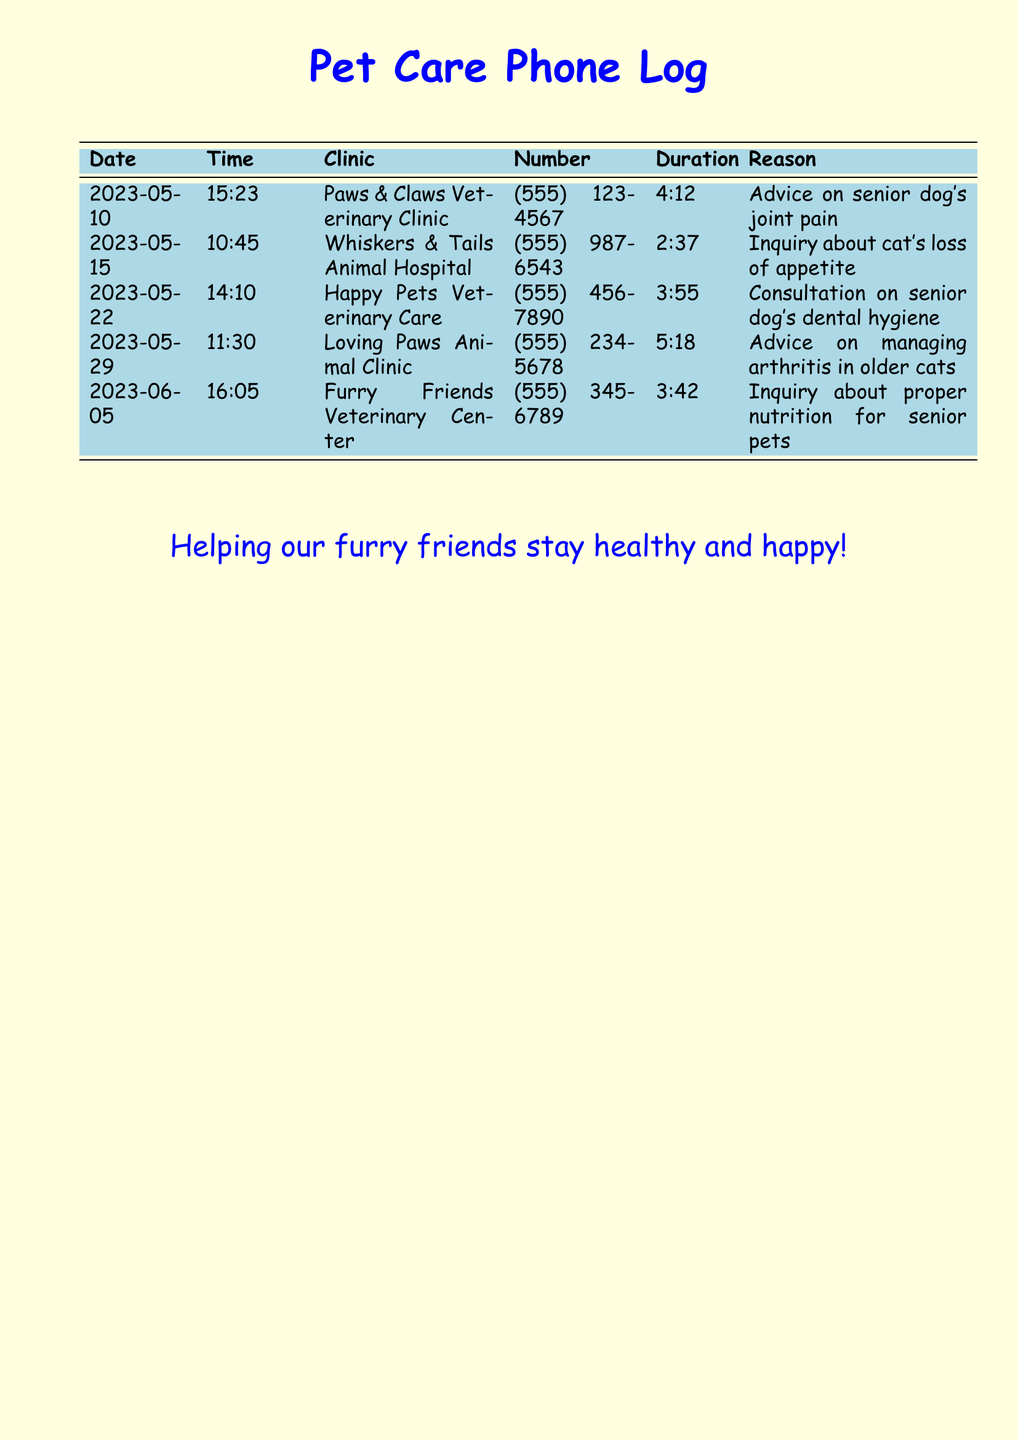what is the name of the clinic that provided advice on joint pain? The clinic that provided advice on joint pain is indicated in the document on the date 2023-05-10.
Answer: Paws & Claws Veterinary Clinic what was the duration of the call regarding the cat's loss of appetite? The duration of the call for the cat's loss of appetite on 2023-05-15 is specified in the document.
Answer: 2:37 how many calls were made to Loving Paws Animal Clinic? The document shows that there was only one call made to Loving Paws Animal Clinic on 2023-05-29.
Answer: 1 what health concern was discussed during the call with Happy Pets Veterinary Care? The health concern discussed during the call with Happy Pets Veterinary Care on 2023-05-22 is mentioned.
Answer: Dental hygiene which clinic was contacted for advice on managing arthritis in older cats? The document indicates the clinic contacted for arthritis management advice on 2023-05-29.
Answer: Loving Paws Animal Clinic 